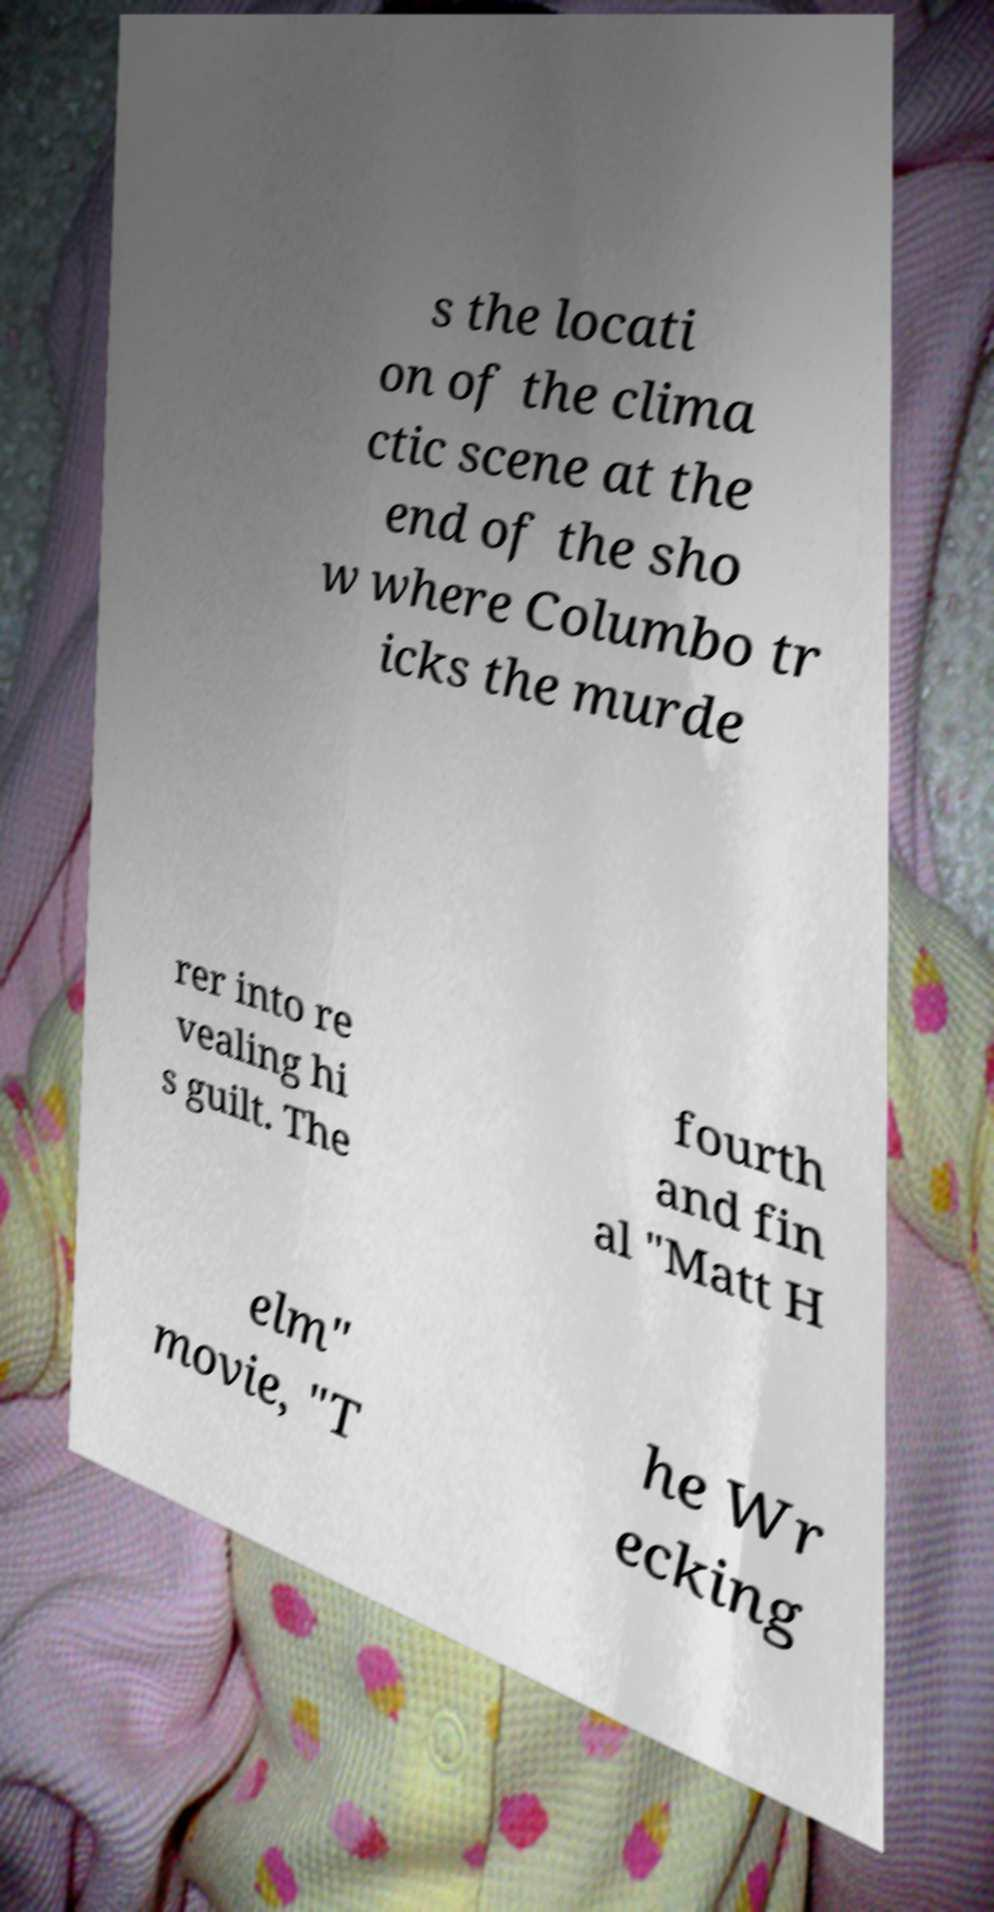Could you extract and type out the text from this image? s the locati on of the clima ctic scene at the end of the sho w where Columbo tr icks the murde rer into re vealing hi s guilt. The fourth and fin al "Matt H elm" movie, "T he Wr ecking 